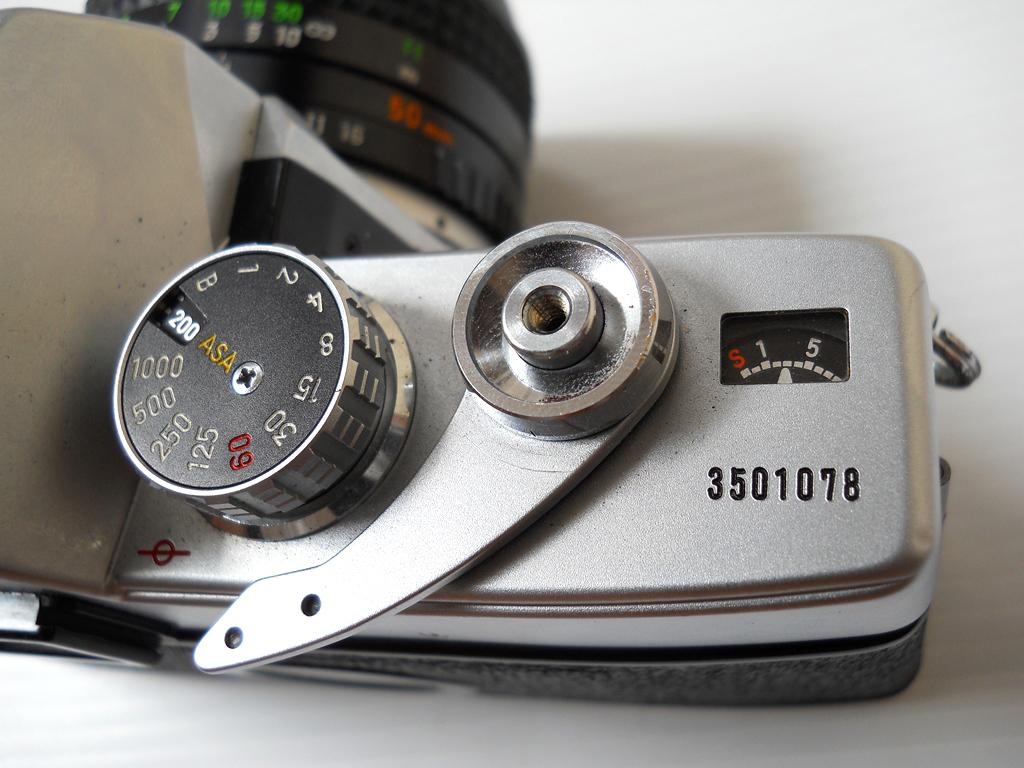What object is the main focus of the image? There is a camera in the image. What feature can be seen on the camera? The camera has numbers on it. What color is the surface the camera is on? The camera is on a white surface. What type of thunder can be heard in the image? There is no thunder present in the image, as it is a still image of a camera. How many eggs are visible in the image? There are no eggs present in the image; it features a camera on a white surface. 